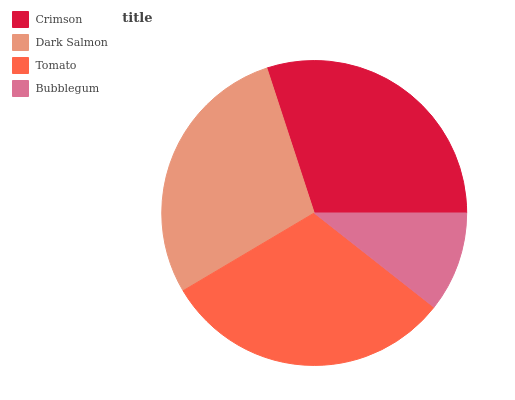Is Bubblegum the minimum?
Answer yes or no. Yes. Is Tomato the maximum?
Answer yes or no. Yes. Is Dark Salmon the minimum?
Answer yes or no. No. Is Dark Salmon the maximum?
Answer yes or no. No. Is Crimson greater than Dark Salmon?
Answer yes or no. Yes. Is Dark Salmon less than Crimson?
Answer yes or no. Yes. Is Dark Salmon greater than Crimson?
Answer yes or no. No. Is Crimson less than Dark Salmon?
Answer yes or no. No. Is Crimson the high median?
Answer yes or no. Yes. Is Dark Salmon the low median?
Answer yes or no. Yes. Is Bubblegum the high median?
Answer yes or no. No. Is Tomato the low median?
Answer yes or no. No. 